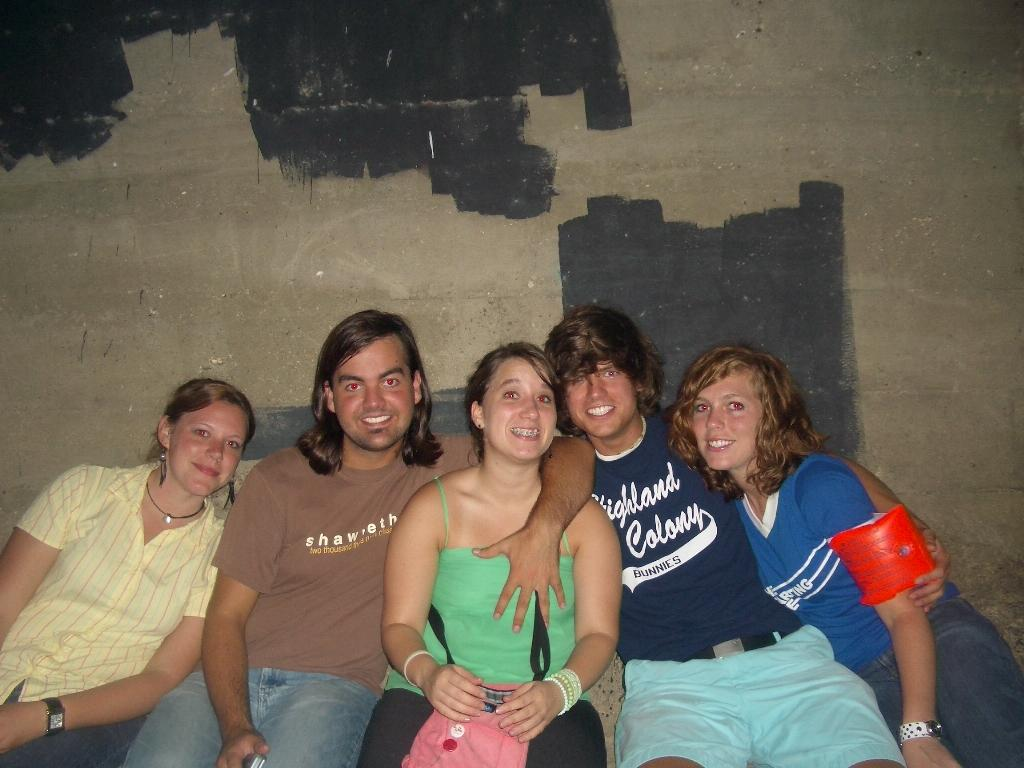Who or what is present in the image? There are people in the image. What can be seen in the background of the image? There is a wall visible in the image. Can you describe the appearance of the wall? Some areas of the wall have black paint. What type of ice can be seen melting on the wall in the image? There is no ice present in the image, and therefore no ice can be seen melting on the wall. 